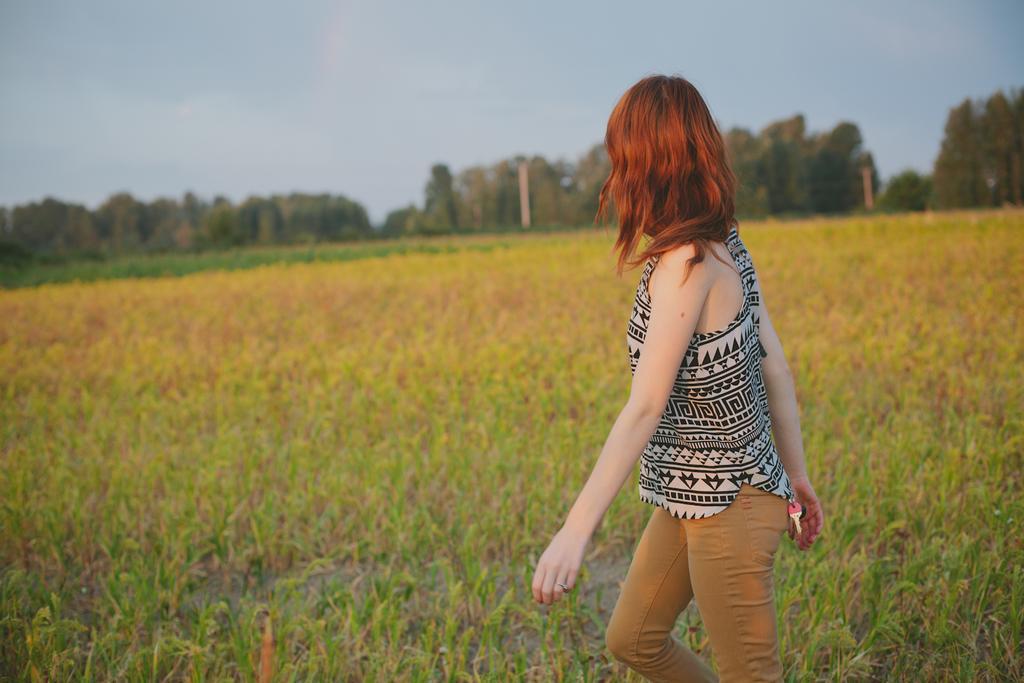Could you give a brief overview of what you see in this image? In this picture we can see a girl walking on the ground, grass, trees and in the background we can see the sky. 